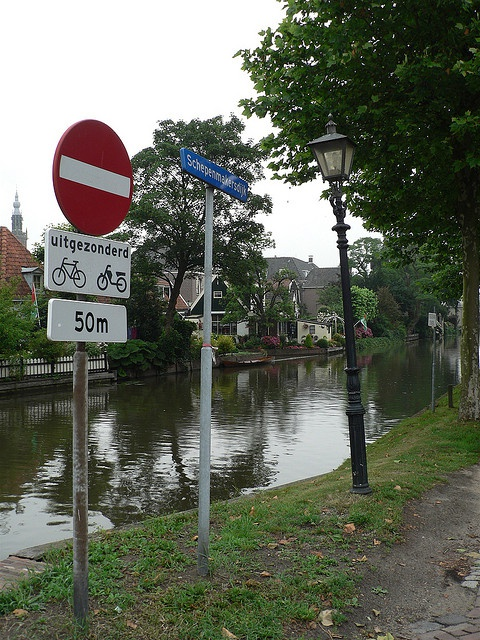Describe the objects in this image and their specific colors. I can see a bicycle in white, darkgray, black, gray, and lightgray tones in this image. 